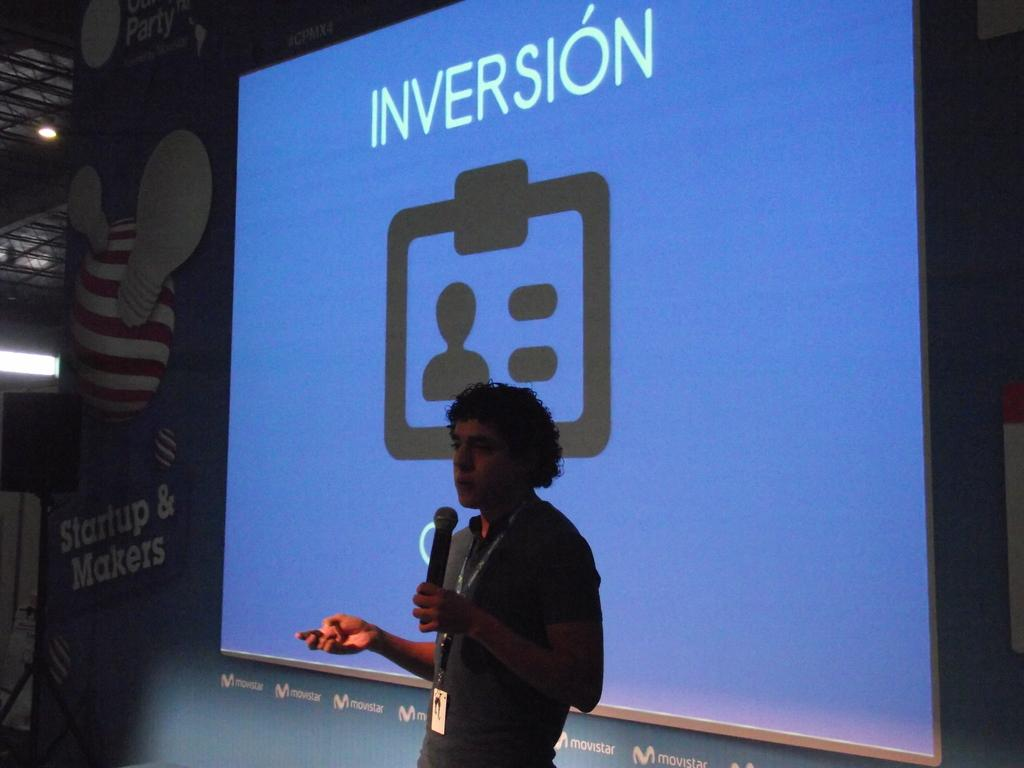Who is present in the image? There is a man in the image. What is the man holding in the image? The man is holding a microphone. What can be seen in the background of the image? There is a projector screen in the background of the image. Can you describe the lighting in the image? There is a light on the left side of the image. How many cushions are on the stage in the image? There is no stage or cushions present in the image. 